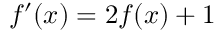Convert formula to latex. <formula><loc_0><loc_0><loc_500><loc_500>f ^ { \prime } ( x ) = 2 f ( x ) + 1</formula> 